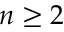<formula> <loc_0><loc_0><loc_500><loc_500>n \geq 2</formula> 